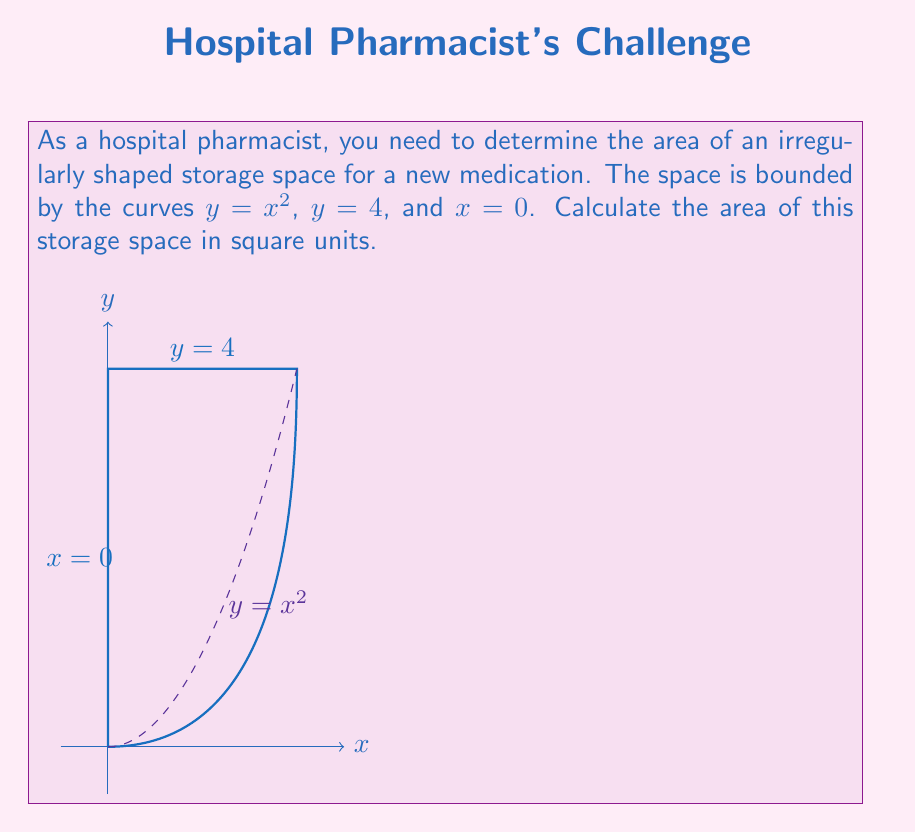Can you solve this math problem? To find the area of this irregular storage space, we need to use integration. Here's a step-by-step approach:

1) The region is bounded by $y = x^2$ from below, $y = 4$ from above, and $x = 0$ from the left.

2) We need to find the point of intersection between $y = x^2$ and $y = 4$:
   $$x^2 = 4$$
   $$x = \pm 2$$
   Since we're only considering the positive x-axis, the right boundary is at $x = 2$.

3) The area can be calculated by integrating the difference between the upper and lower curves:

   $$A = \int_0^2 (4 - x^2) dx$$

4) Expand the integral:
   $$A = \int_0^2 4 dx - \int_0^2 x^2 dx$$

5) Integrate:
   $$A = [4x]_0^2 - [\frac{1}{3}x^3]_0^2$$

6) Evaluate the definite integral:
   $$A = (8 - 0) - (\frac{8}{3} - 0)$$
   $$A = 8 - \frac{8}{3}$$

7) Simplify:
   $$A = \frac{24}{3} - \frac{8}{3} = \frac{16}{3}$$

Therefore, the area of the irregular storage space is $\frac{16}{3}$ square units.
Answer: $\frac{16}{3}$ square units 